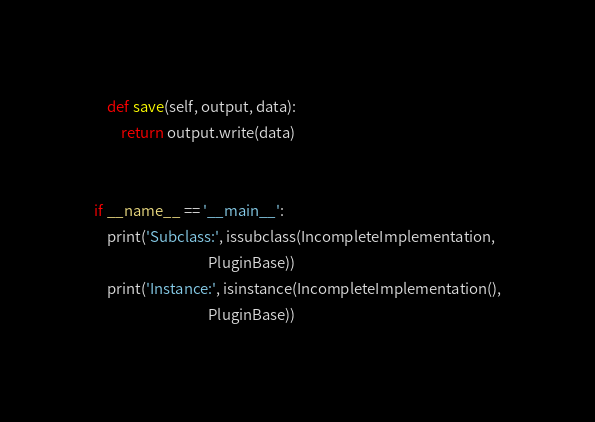Convert code to text. <code><loc_0><loc_0><loc_500><loc_500><_Python_>    def save(self, output, data):
        return output.write(data)


if __name__ == '__main__':
    print('Subclass:', issubclass(IncompleteImplementation,
                                  PluginBase))
    print('Instance:', isinstance(IncompleteImplementation(),
                                  PluginBase))
</code> 